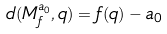Convert formula to latex. <formula><loc_0><loc_0><loc_500><loc_500>d ( { M } ^ { a _ { 0 } } _ { f } , q ) = f ( q ) - a _ { 0 }</formula> 